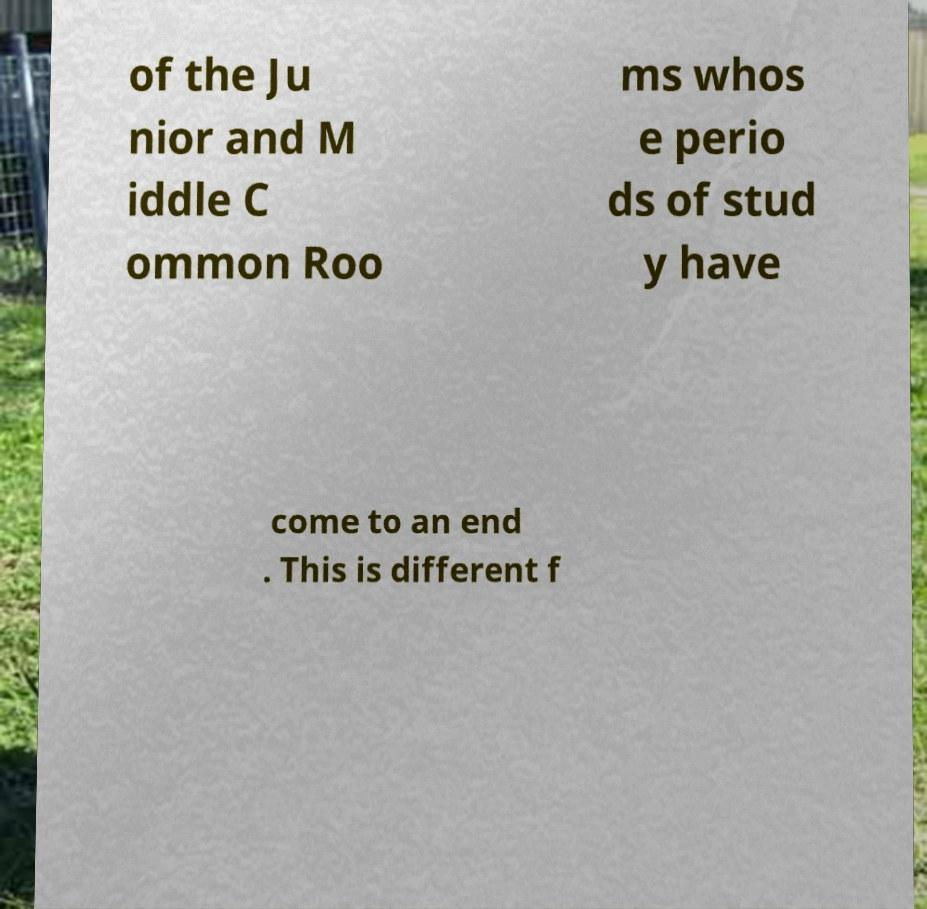Please identify and transcribe the text found in this image. of the Ju nior and M iddle C ommon Roo ms whos e perio ds of stud y have come to an end . This is different f 